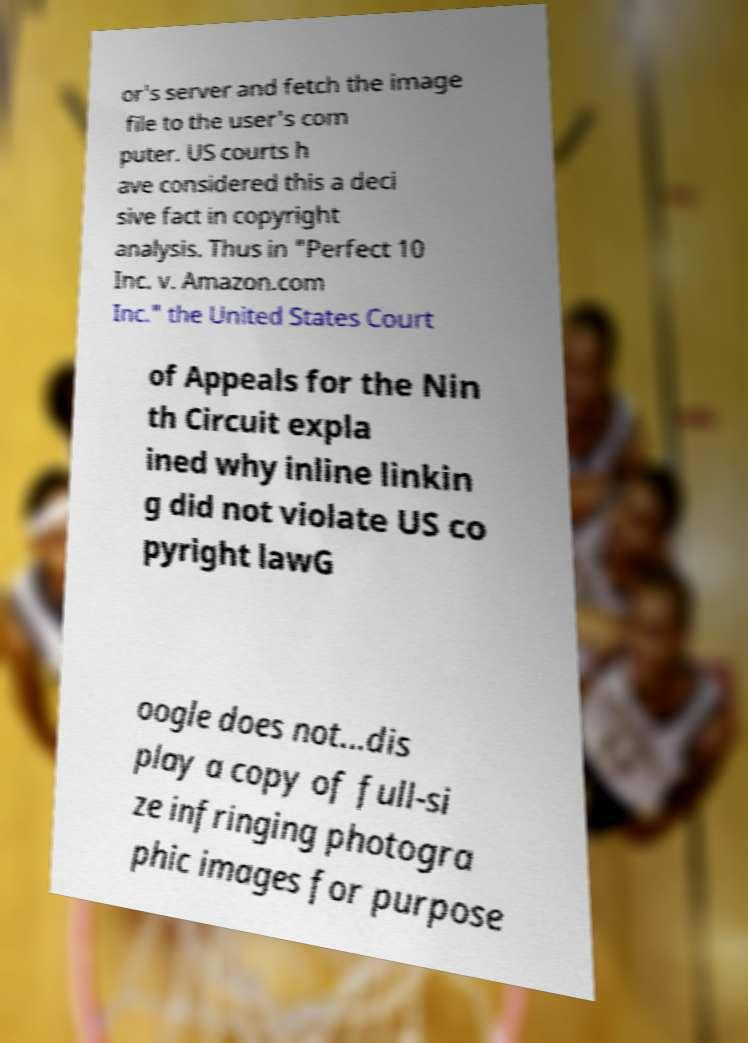What messages or text are displayed in this image? I need them in a readable, typed format. or's server and fetch the image file to the user's com puter. US courts h ave considered this a deci sive fact in copyright analysis. Thus in "Perfect 10 Inc. v. Amazon.com Inc." the United States Court of Appeals for the Nin th Circuit expla ined why inline linkin g did not violate US co pyright lawG oogle does not...dis play a copy of full-si ze infringing photogra phic images for purpose 